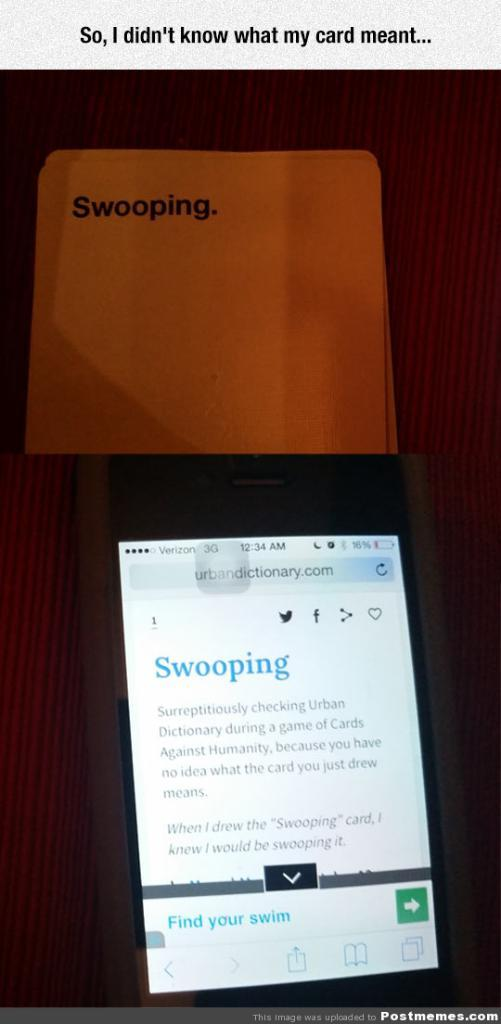<image>
Describe the image concisely. A black smartphone is accessing the website urbandictionary.com. 